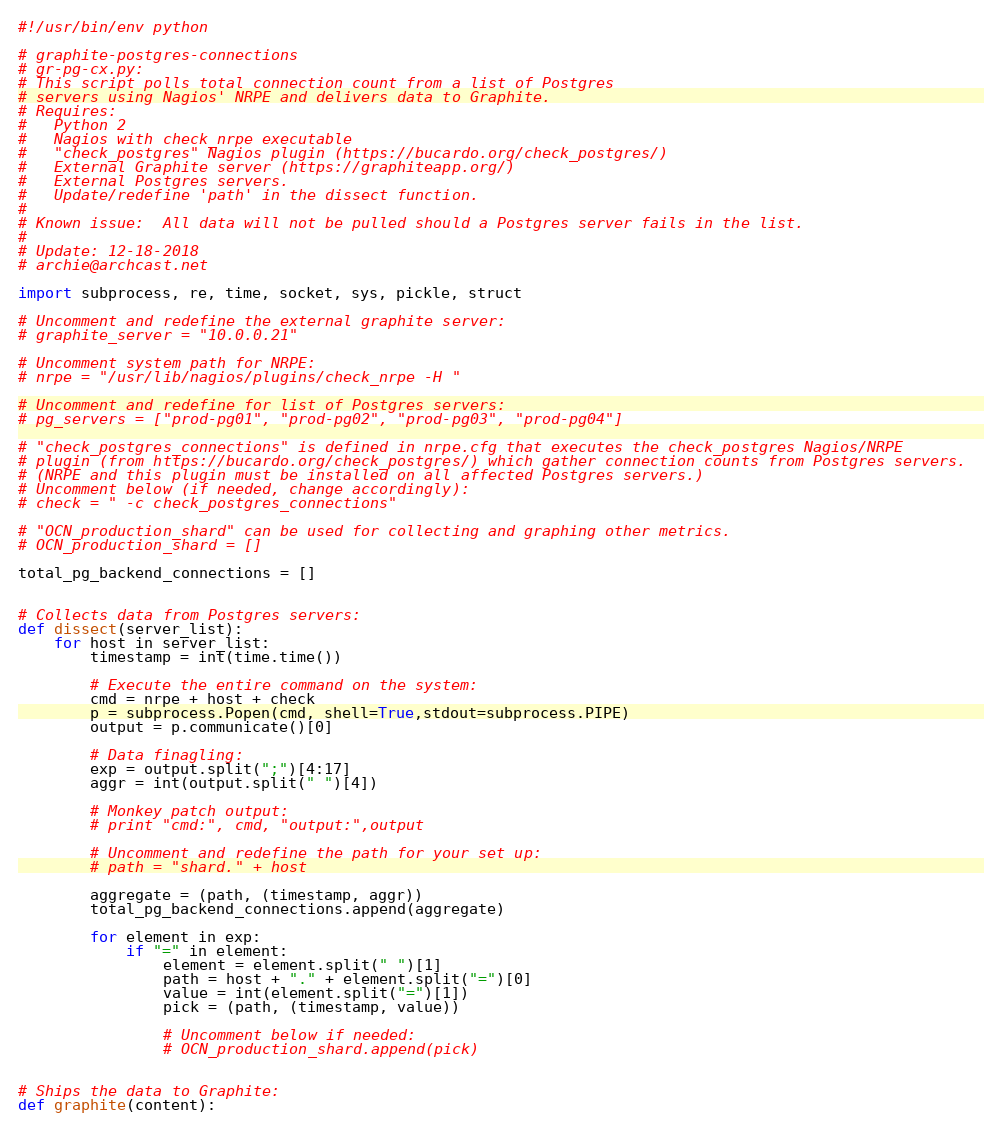Convert code to text. <code><loc_0><loc_0><loc_500><loc_500><_Python_>#!/usr/bin/env python

# graphite-postgres-connections
# gr-pg-cx.py:
# This script polls total connection count from a list of Postgres
# servers using Nagios' NRPE and delivers data to Graphite.
# Requires:
# 	Python 2
#	Nagios with check_nrpe executable
# 	"check_postgres" Nagios plugin (https://bucardo.org/check_postgres/)
# 	External Graphite server (https://graphiteapp.org/)
# 	External Postgres servers.
# 	Update/redefine 'path' in the dissect function.
#
# Known issue:  All data will not be pulled should a Postgres server fails in the list.
#
# Update: 12-18-2018
# archie@archcast.net

import subprocess, re, time, socket, sys, pickle, struct

# Uncomment and redefine the external graphite server:
# graphite_server = "10.0.0.21"

# Uncomment system path for NRPE:
# nrpe = "/usr/lib/nagios/plugins/check_nrpe -H "

# Uncomment and redefine for list of Postgres servers:
# pg_servers = ["prod-pg01", "prod-pg02", "prod-pg03", "prod-pg04"]

# "check_postgres_connections" is defined in nrpe.cfg that executes the check_postgres Nagios/NRPE
# plugin (from https://bucardo.org/check_postgres/) which gather connection counts from Postgres servers.
# (NRPE and this plugin must be installed on all affected Postgres servers.)
# Uncomment below (if needed, change accordingly):
# check = " -c check_postgres_connections"

# "OCN_production_shard" can be used for collecting and graphing other metrics.
# OCN_production_shard = []

total_pg_backend_connections = []


# Collects data from Postgres servers:
def dissect(server_list):
	for host in server_list:
		timestamp = int(time.time())
		
		# Execute the entire command on the system:
		cmd = nrpe + host + check
		p = subprocess.Popen(cmd, shell=True,stdout=subprocess.PIPE)
		output = p.communicate()[0]

		# Data finagling:
		exp = output.split(";")[4:17]
		aggr = int(output.split(" ")[4])

		# Monkey patch output:
		# print "cmd:", cmd, "output:",output

		# Uncomment and redefine the path for your set up:
		# path = "shard." + host

		aggregate = (path, (timestamp, aggr))
		total_pg_backend_connections.append(aggregate)
		
		for element in exp:
			if "=" in element:
				element = element.split(" ")[1]
				path = host + "." + element.split("=")[0]
				value = int(element.split("=")[1])
				pick = (path, (timestamp, value))

				# Uncomment below if needed:
				# OCN_production_shard.append(pick)


# Ships the data to Graphite:	
def graphite(content):</code> 